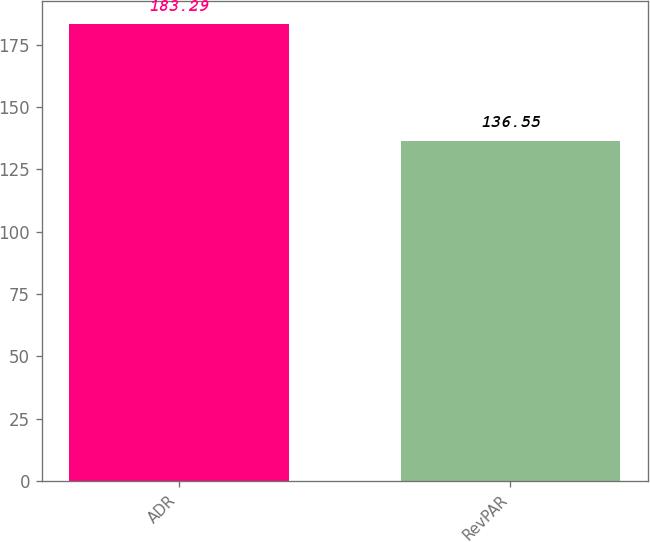<chart> <loc_0><loc_0><loc_500><loc_500><bar_chart><fcel>ADR<fcel>RevPAR<nl><fcel>183.29<fcel>136.55<nl></chart> 